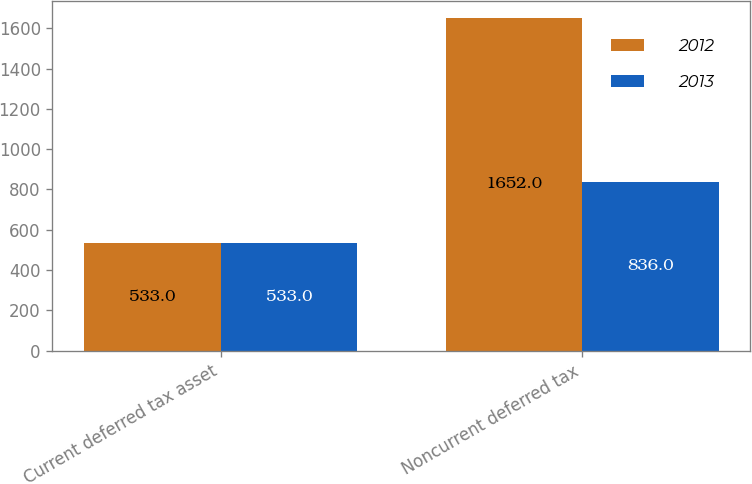Convert chart to OTSL. <chart><loc_0><loc_0><loc_500><loc_500><stacked_bar_chart><ecel><fcel>Current deferred tax asset<fcel>Noncurrent deferred tax<nl><fcel>2012<fcel>533<fcel>1652<nl><fcel>2013<fcel>533<fcel>836<nl></chart> 